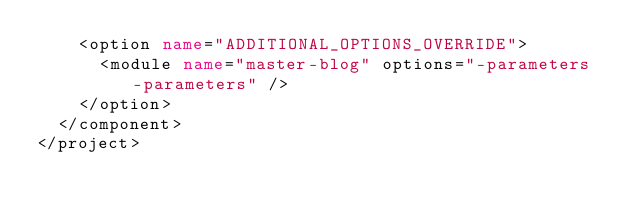<code> <loc_0><loc_0><loc_500><loc_500><_XML_>    <option name="ADDITIONAL_OPTIONS_OVERRIDE">
      <module name="master-blog" options="-parameters -parameters" />
    </option>
  </component>
</project></code> 